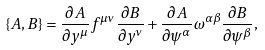<formula> <loc_0><loc_0><loc_500><loc_500>\{ A , B \} = \frac { \partial A } { \partial y ^ { \mu } } f ^ { \mu \nu } \frac { \partial B } { \partial y ^ { \nu } } + \frac { \partial A } { \partial \psi ^ { \alpha } } \omega ^ { \alpha \beta } \frac { \partial B } { \partial \psi ^ { \beta } } ,</formula> 